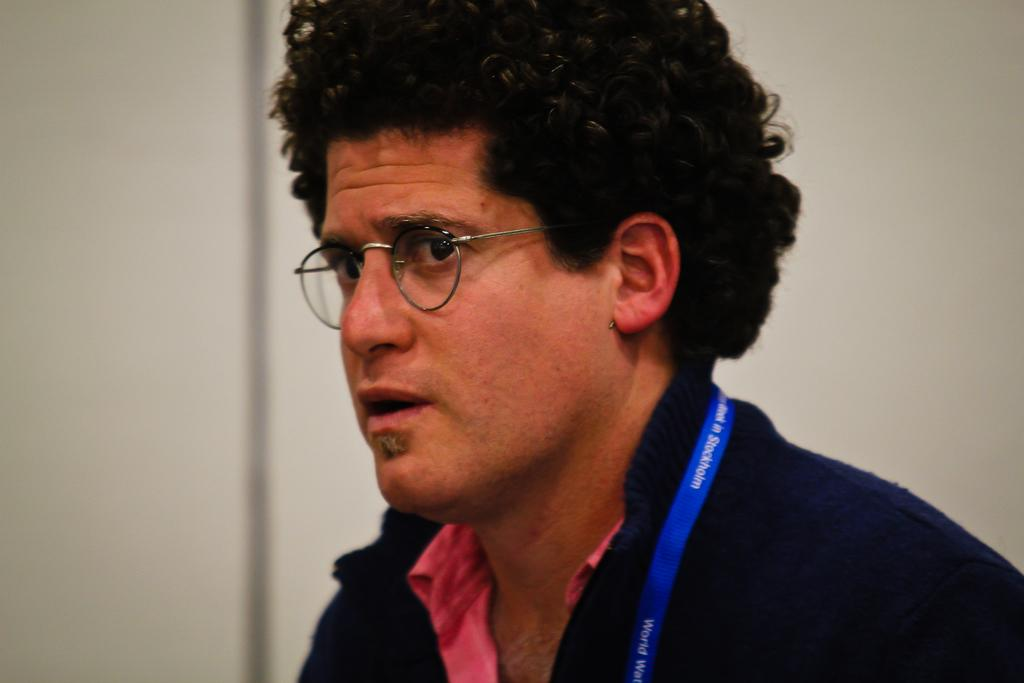Who is present in the image? There is a man in the image. What is the man wearing? The man is wearing clothes. Does the man have any identification in the image? Yes, the man has an identity card. What type of eyewear is the man wearing? The man is wearing spectacles. What is the color of the background in the image? The background of the image is white. What type of liquid can be seen in the man's hand in the image? There is no liquid visible in the man's hand in the image. Can you tell me how many turkeys are present in the image? There are no turkeys present in the image. 